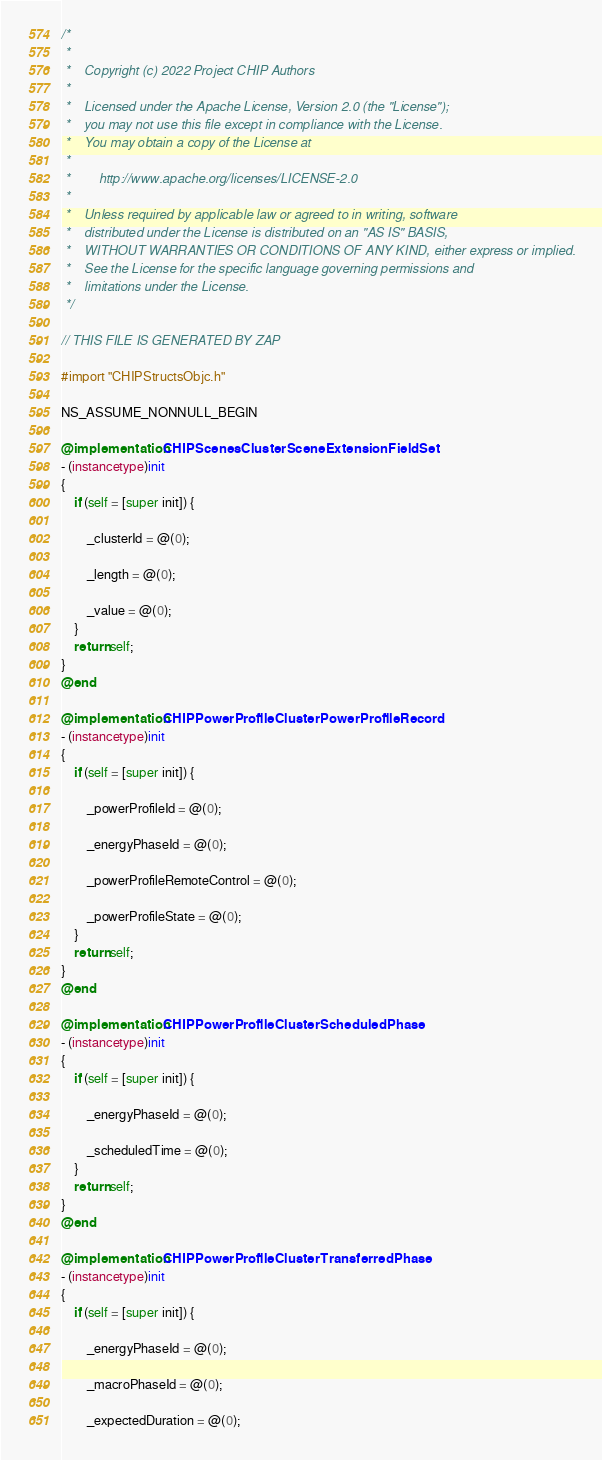<code> <loc_0><loc_0><loc_500><loc_500><_ObjectiveC_>/*
 *
 *    Copyright (c) 2022 Project CHIP Authors
 *
 *    Licensed under the Apache License, Version 2.0 (the "License");
 *    you may not use this file except in compliance with the License.
 *    You may obtain a copy of the License at
 *
 *        http://www.apache.org/licenses/LICENSE-2.0
 *
 *    Unless required by applicable law or agreed to in writing, software
 *    distributed under the License is distributed on an "AS IS" BASIS,
 *    WITHOUT WARRANTIES OR CONDITIONS OF ANY KIND, either express or implied.
 *    See the License for the specific language governing permissions and
 *    limitations under the License.
 */

// THIS FILE IS GENERATED BY ZAP

#import "CHIPStructsObjc.h"

NS_ASSUME_NONNULL_BEGIN

@implementation CHIPScenesClusterSceneExtensionFieldSet
- (instancetype)init
{
    if (self = [super init]) {

        _clusterId = @(0);

        _length = @(0);

        _value = @(0);
    }
    return self;
}
@end

@implementation CHIPPowerProfileClusterPowerProfileRecord
- (instancetype)init
{
    if (self = [super init]) {

        _powerProfileId = @(0);

        _energyPhaseId = @(0);

        _powerProfileRemoteControl = @(0);

        _powerProfileState = @(0);
    }
    return self;
}
@end

@implementation CHIPPowerProfileClusterScheduledPhase
- (instancetype)init
{
    if (self = [super init]) {

        _energyPhaseId = @(0);

        _scheduledTime = @(0);
    }
    return self;
}
@end

@implementation CHIPPowerProfileClusterTransferredPhase
- (instancetype)init
{
    if (self = [super init]) {

        _energyPhaseId = @(0);

        _macroPhaseId = @(0);

        _expectedDuration = @(0);
</code> 